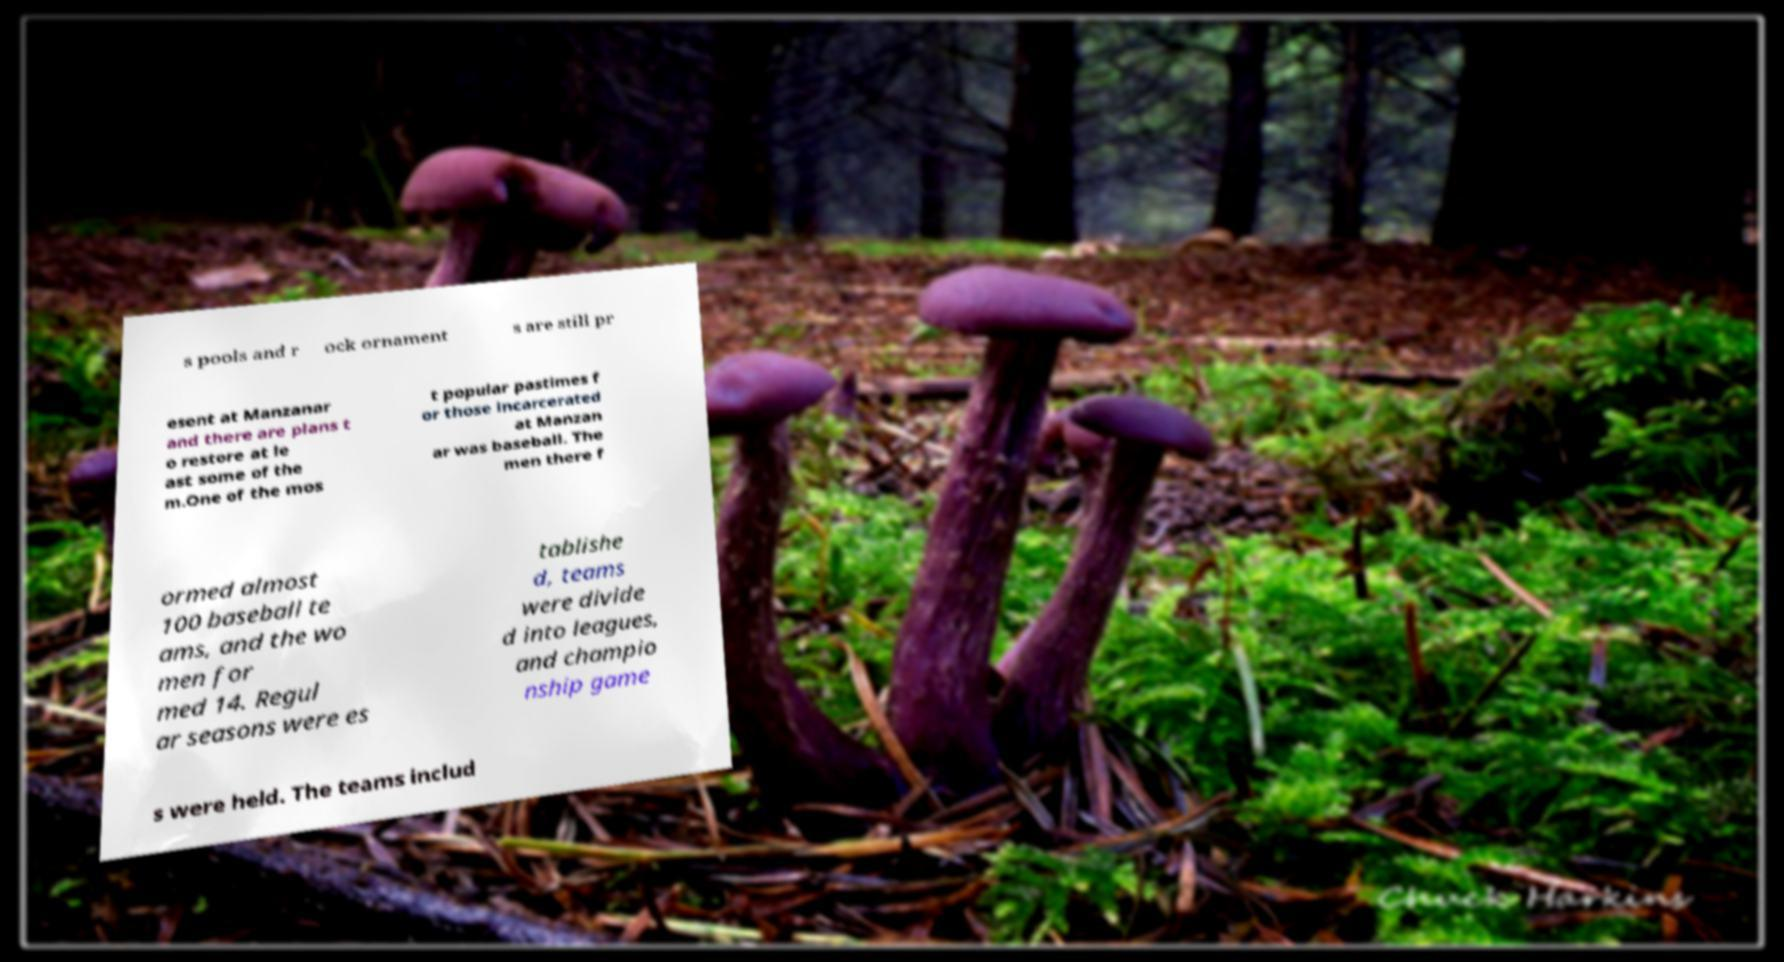Can you accurately transcribe the text from the provided image for me? s pools and r ock ornament s are still pr esent at Manzanar and there are plans t o restore at le ast some of the m.One of the mos t popular pastimes f or those incarcerated at Manzan ar was baseball. The men there f ormed almost 100 baseball te ams, and the wo men for med 14. Regul ar seasons were es tablishe d, teams were divide d into leagues, and champio nship game s were held. The teams includ 